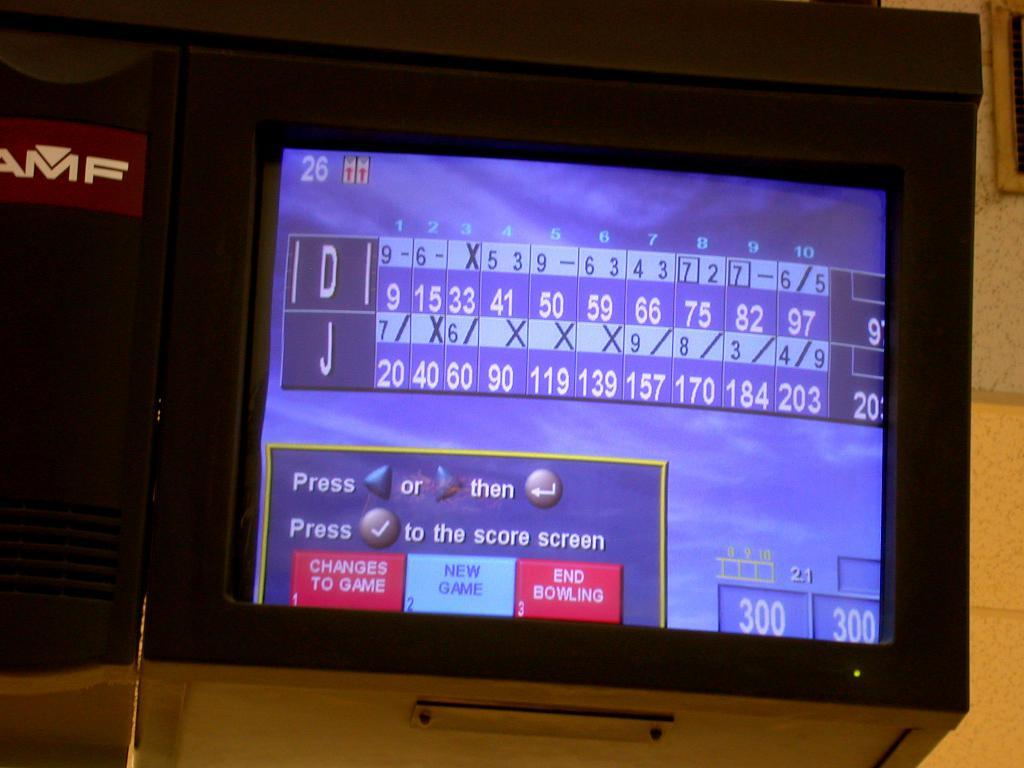<image>
Present a compact description of the photo's key features. A bowling alley scoreboard showing the scores between D and J. 